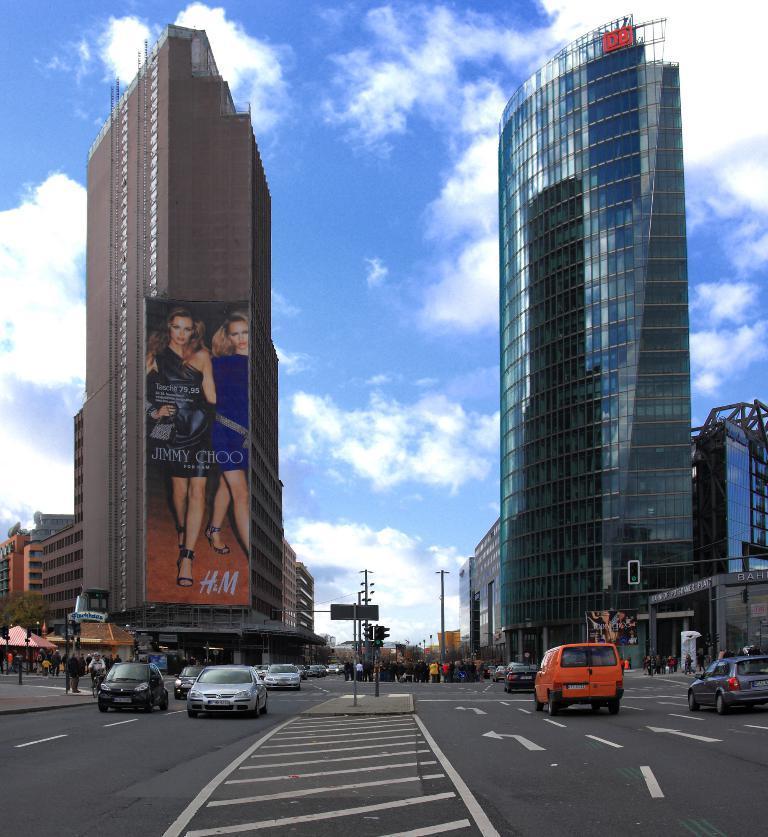Could you give a brief overview of what you see in this image? In the center of the image we can see the traffic lights, poles, road are present. A group of people are standing in the middle of the image. On the right and left side of the image we can see the buildings, truck, cars, trees are present. At the top of the image clouds are present in the sky. At the bottom of the image road is present. 